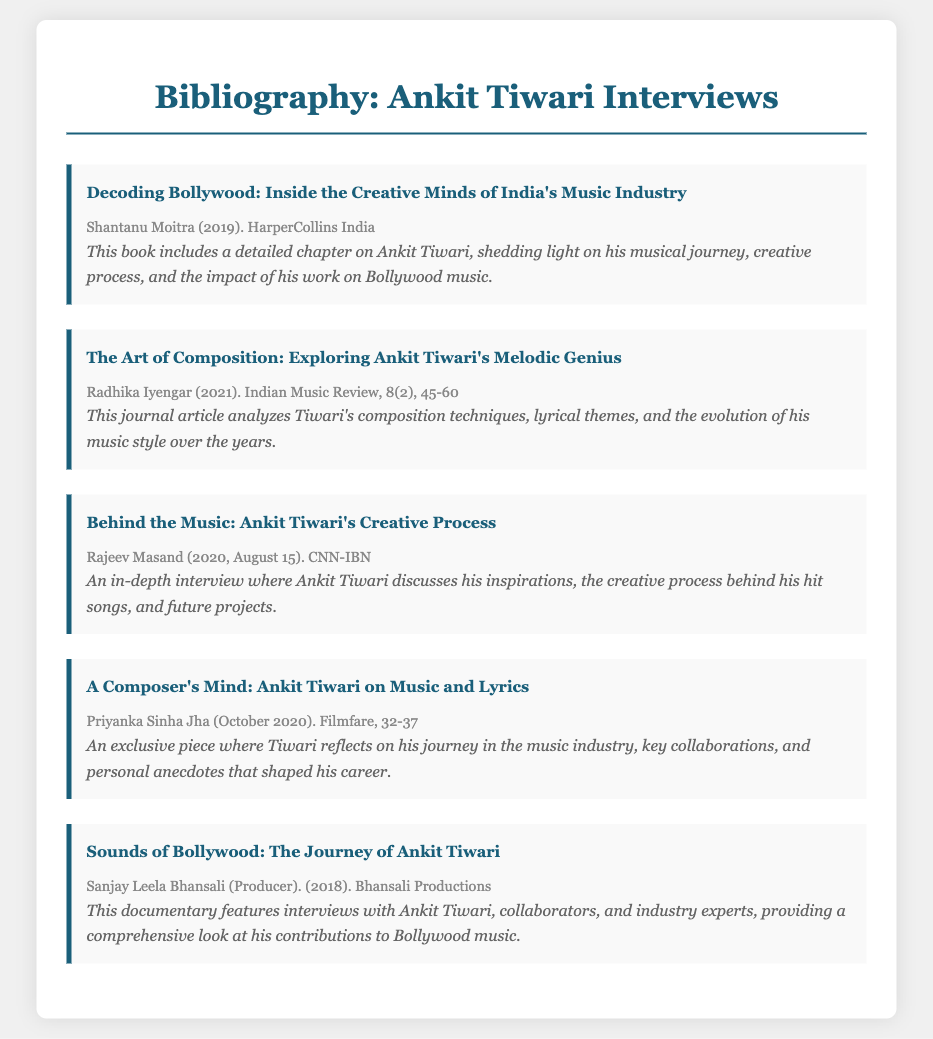What is the title of the book that includes a chapter on Ankit Tiwari? The title provided in the document is "Decoding Bollywood: Inside the Creative Minds of India's Music Industry."
Answer: Decoding Bollywood: Inside the Creative Minds of India's Music Industry Who is the author of the article analyzing Tiwari's composition techniques? The author mentioned for the article is Radhika Iyengar.
Answer: Radhika Iyengar In what year was the interview published where Tiwari discusses his inspirations? The year stated in the document is 2020.
Answer: 2020 What is the primary focus of the documentary featuring Ankit Tiwari? The documentary focuses on Tiwari's contributions to Bollywood music.
Answer: Contributions to Bollywood music How many pages does the Filmfare article about Ankit Tiwari cover? The page range mentioned for the article is 32-37, indicating it covers 6 pages.
Answer: 32-37 What is the name of the producer of the documentary featuring Ankit Tiwari? The producer's name provided is Sanjay Leela Bhansali.
Answer: Sanjay Leela Bhansali Which publication included an exclusive piece on Tiwari's journey in the music industry? The document states that the exclusive piece was published in Filmfare.
Answer: Filmfare What is the publication year of the book that discusses Ankit Tiwari's musical journey? The publication year for the book is 2019.
Answer: 2019 